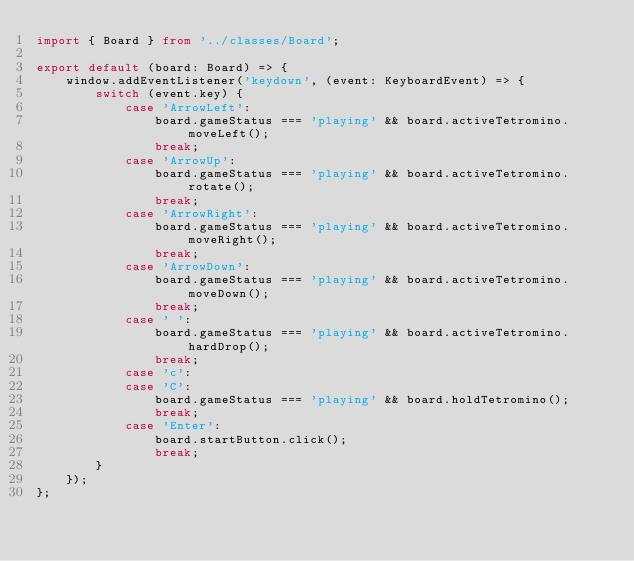Convert code to text. <code><loc_0><loc_0><loc_500><loc_500><_TypeScript_>import { Board } from '../classes/Board';

export default (board: Board) => {
	window.addEventListener('keydown', (event: KeyboardEvent) => {
		switch (event.key) {
			case 'ArrowLeft':
				board.gameStatus === 'playing' && board.activeTetromino.moveLeft();
				break;
			case 'ArrowUp':
				board.gameStatus === 'playing' && board.activeTetromino.rotate();
				break;
			case 'ArrowRight':
				board.gameStatus === 'playing' && board.activeTetromino.moveRight();
				break;
			case 'ArrowDown':
				board.gameStatus === 'playing' && board.activeTetromino.moveDown();
				break;
			case ' ':
				board.gameStatus === 'playing' && board.activeTetromino.hardDrop();
				break;
			case 'c':
			case 'C':
				board.gameStatus === 'playing' && board.holdTetromino();
				break;
			case 'Enter':
				board.startButton.click();
				break;
		}
	});
};
</code> 